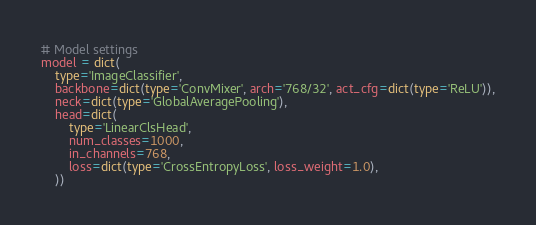<code> <loc_0><loc_0><loc_500><loc_500><_Python_># Model settings
model = dict(
    type='ImageClassifier',
    backbone=dict(type='ConvMixer', arch='768/32', act_cfg=dict(type='ReLU')),
    neck=dict(type='GlobalAveragePooling'),
    head=dict(
        type='LinearClsHead',
        num_classes=1000,
        in_channels=768,
        loss=dict(type='CrossEntropyLoss', loss_weight=1.0),
    ))
</code> 